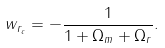Convert formula to latex. <formula><loc_0><loc_0><loc_500><loc_500>w _ { r _ { c } } = - \frac { 1 } { 1 + \Omega _ { m } + \Omega _ { r } } .</formula> 